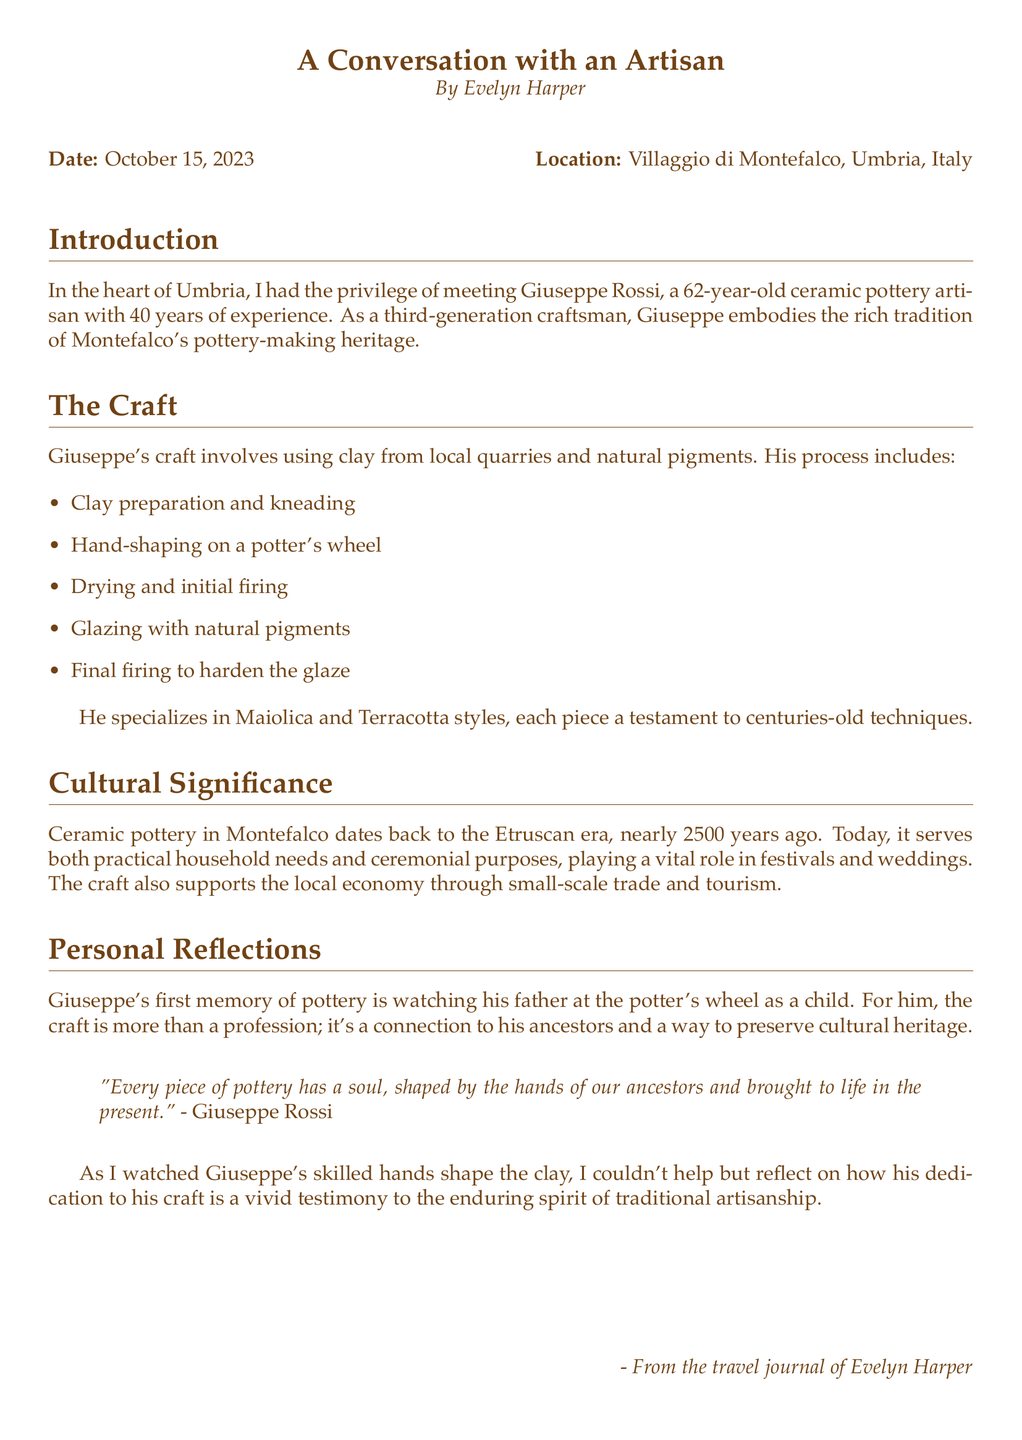What is the name of the artisan? The document explicitly states the name of the artisan as Giuseppe Rossi.
Answer: Giuseppe Rossi How many years of experience does Giuseppe have? The document mentions that Giuseppe has 40 years of experience in pottery-making.
Answer: 40 years In which village does Giuseppe work? The location of the artisan's work is stated as Villaggio di Montefalco.
Answer: Villaggio di Montefalco What styles does Giuseppe specialize in? The document lists the styles Giuseppe specializes in as Maiolica and Terracotta.
Answer: Maiolica and Terracotta What is the historical significance of pottery in Montefalco? The document notes that ceramic pottery in Montefalco dates back to the Etruscan era, nearly 2500 years ago.
Answer: Etruscan era What connection does Giuseppe feel towards his craft? The document mentions that for Giuseppe, the craft is a way to preserve cultural heritage and connect with his ancestors.
Answer: Connection to ancestors What process involves clay preparation and kneading? The document outlines the steps of Giuseppe's craft, including clay preparation and kneading as part of the ceramic-making process.
Answer: Clay preparation and kneading What is the purpose of the pottery during festivals? The document states that ceramic pottery plays a vital role in ceremonies, including festivals and weddings.
Answer: Ceremonial purposes 